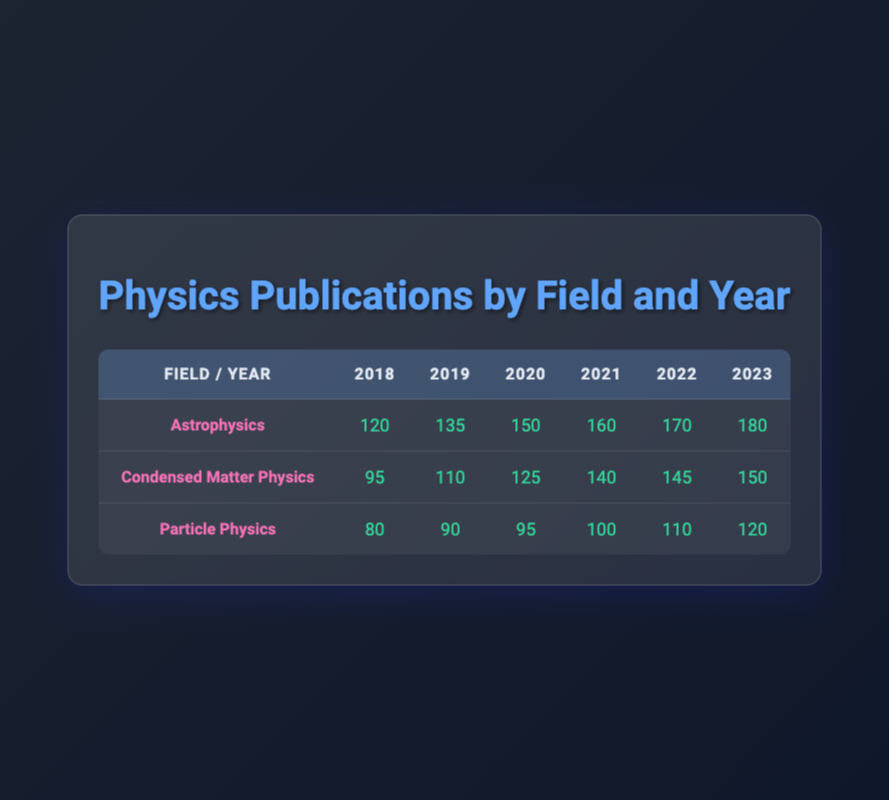What is the total number of publications in Astrophysics in 2022? The publications in Astrophysics for 2022 is listed directly in the table, which shows a total of 170 publications.
Answer: 170 Which year saw the highest number of Particle Physics publications? By checking each year for Particle Physics, it's noted that 2023 has the highest publication count with 120.
Answer: 2023 How many more publications were there in Astrophysics in 2023 compared to 2018? The publications in 2023 are 180, and in 2018 they were 120. The difference is calculated as 180 - 120 = 60.
Answer: 60 What is the average number of publications in Condensed Matter Physics from 2018 to 2023? The publication counts are 95, 110, 125, 140, 145, and 150. Summing these values gives 95 + 110 + 125 + 140 + 145 + 150 = 765. There are 6 data points, so the average is 765 / 6 = 127.5.
Answer: 127.5 Did the number of publications in Particle Physics increase every year from 2018 to 2023? Analyzing the data, the publications for Particle Physics are 80, 90, 95, 100, 110, and 120, showing an increase each year. Therefore, the answer is yes.
Answer: Yes What is the total number of publications across all fields in 2019? For 2019, the publications in each field are 135 (Astrophysics) + 110 (Condensed Matter Physics) + 90 (Particle Physics) = 335. Thus, the total is 335 publications.
Answer: 335 Which research field had the highest publication count in 2020? In 2020, Astrophysics had 150 publications, Condensed Matter Physics had 125, and Particle Physics had 95. Thus, Astrophysics had the highest count.
Answer: Astrophysics How many publications does Condensed Matter Physics have in total over the years? Adding the total for each year gives: 95 + 110 + 125 + 140 + 145 + 150 = 765 publications in total for Condensed Matter Physics over six years.
Answer: 765 What was the publication trend for Astrophysics from 2018 to 2023? Observing the publication figures from 2018 (120), 2019 (135), 2020 (150), 2021 (160), 2022 (170) to 2023 (180), we see a steady increase each year indicating a positive trend.
Answer: Steady increase 